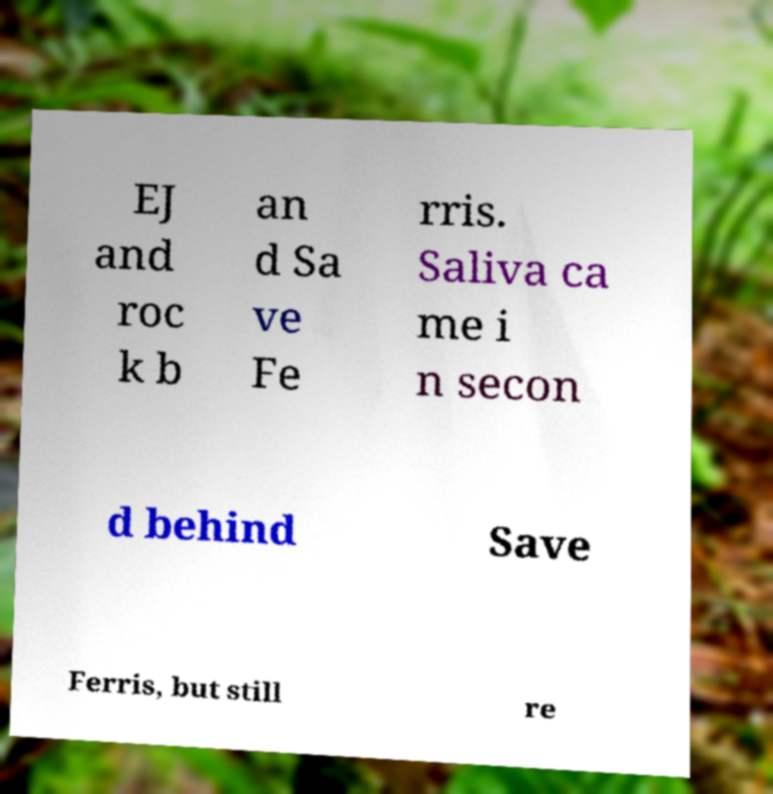For documentation purposes, I need the text within this image transcribed. Could you provide that? EJ and roc k b an d Sa ve Fe rris. Saliva ca me i n secon d behind Save Ferris, but still re 